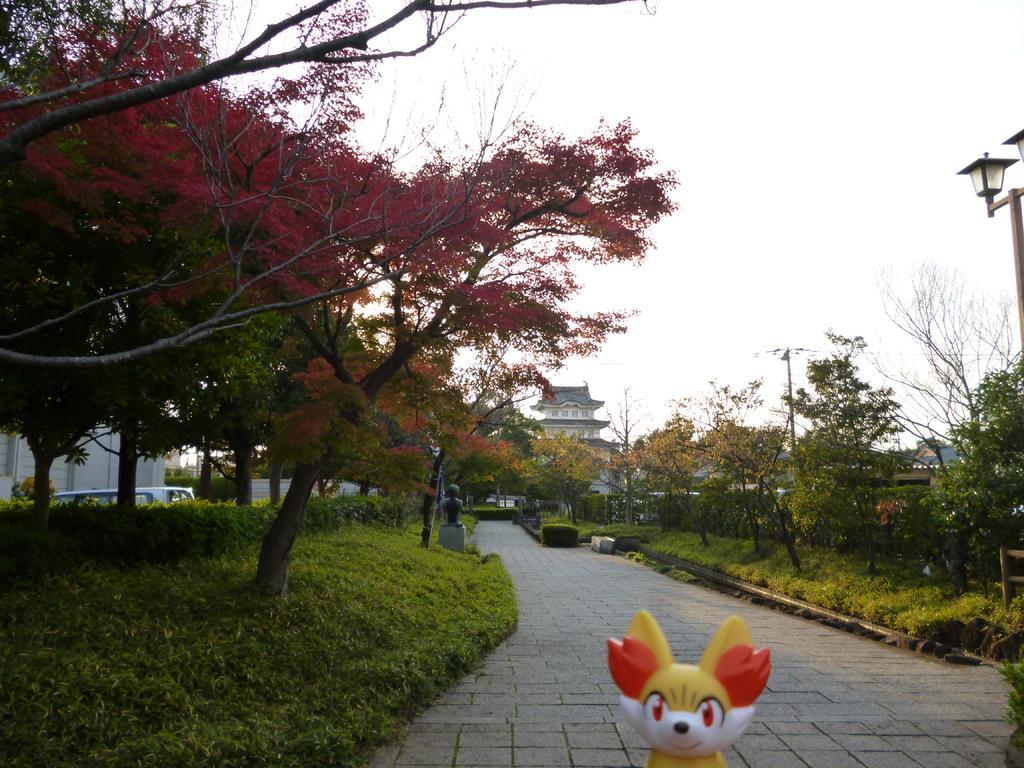How would you summarize this image in a sentence or two? In the image we can see a toy, white, yellow and orange in color. Here we can see footpath, grass and trees. We can even see a building, electric pole, the light pole and electric wires. There are even vehicles and the sky. We can even see there is a sculpture. 